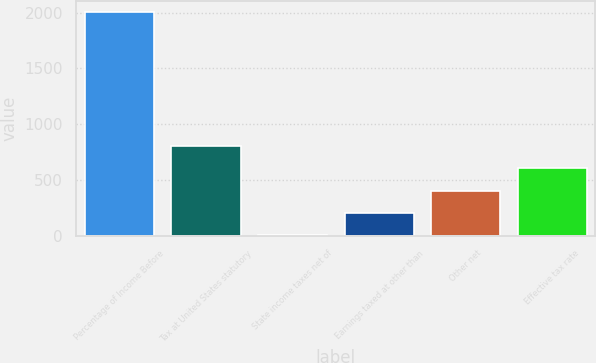Convert chart. <chart><loc_0><loc_0><loc_500><loc_500><bar_chart><fcel>Percentage of Income Before<fcel>Tax at United States statutory<fcel>State income taxes net of<fcel>Earnings taxed at other than<fcel>Other net<fcel>Effective tax rate<nl><fcel>2004<fcel>802.2<fcel>1<fcel>201.3<fcel>401.6<fcel>601.9<nl></chart> 